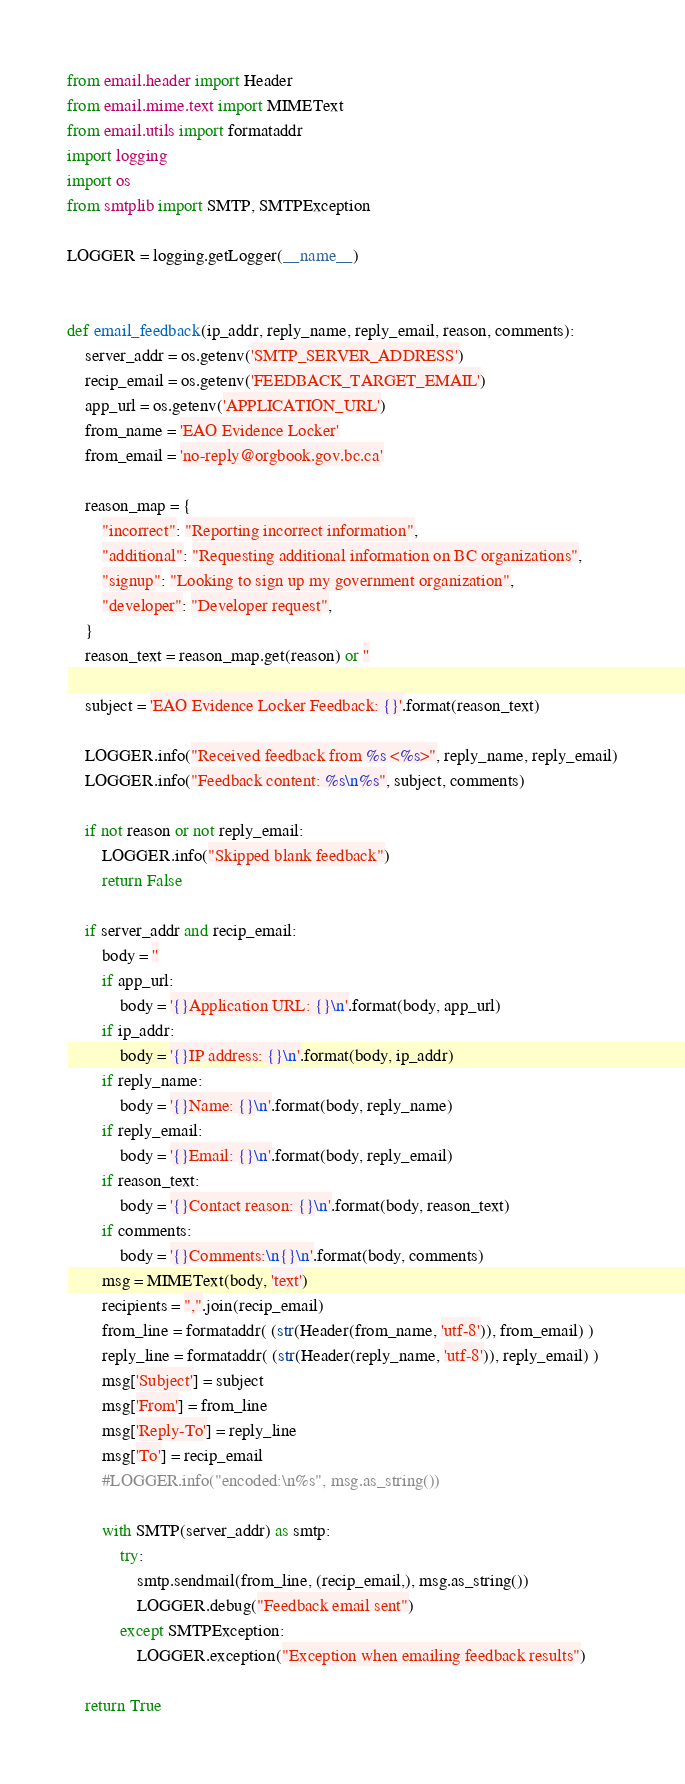<code> <loc_0><loc_0><loc_500><loc_500><_Python_>from email.header import Header
from email.mime.text import MIMEText
from email.utils import formataddr
import logging
import os
from smtplib import SMTP, SMTPException

LOGGER = logging.getLogger(__name__)


def email_feedback(ip_addr, reply_name, reply_email, reason, comments):
    server_addr = os.getenv('SMTP_SERVER_ADDRESS')
    recip_email = os.getenv('FEEDBACK_TARGET_EMAIL')
    app_url = os.getenv('APPLICATION_URL')
    from_name = 'EAO Evidence Locker'
    from_email = 'no-reply@orgbook.gov.bc.ca'

    reason_map = {
        "incorrect": "Reporting incorrect information",
        "additional": "Requesting additional information on BC organizations",
        "signup": "Looking to sign up my government organization",
        "developer": "Developer request",
    }
    reason_text = reason_map.get(reason) or ''

    subject = 'EAO Evidence Locker Feedback: {}'.format(reason_text)

    LOGGER.info("Received feedback from %s <%s>", reply_name, reply_email)
    LOGGER.info("Feedback content: %s\n%s", subject, comments)

    if not reason or not reply_email:
        LOGGER.info("Skipped blank feedback")
        return False

    if server_addr and recip_email:
        body = ''
        if app_url:
            body = '{}Application URL: {}\n'.format(body, app_url)
        if ip_addr:
            body = '{}IP address: {}\n'.format(body, ip_addr)
        if reply_name:
            body = '{}Name: {}\n'.format(body, reply_name)
        if reply_email:
            body = '{}Email: {}\n'.format(body, reply_email)
        if reason_text:
            body = '{}Contact reason: {}\n'.format(body, reason_text)
        if comments:
            body = '{}Comments:\n{}\n'.format(body, comments)
        msg = MIMEText(body, 'text')
        recipients = ",".join(recip_email)
        from_line = formataddr( (str(Header(from_name, 'utf-8')), from_email) )
        reply_line = formataddr( (str(Header(reply_name, 'utf-8')), reply_email) )
        msg['Subject'] = subject
        msg['From'] = from_line
        msg['Reply-To'] = reply_line
        msg['To'] = recip_email
        #LOGGER.info("encoded:\n%s", msg.as_string())

        with SMTP(server_addr) as smtp:
            try:
                smtp.sendmail(from_line, (recip_email,), msg.as_string())
                LOGGER.debug("Feedback email sent")
            except SMTPException:
                LOGGER.exception("Exception when emailing feedback results")

    return True
</code> 